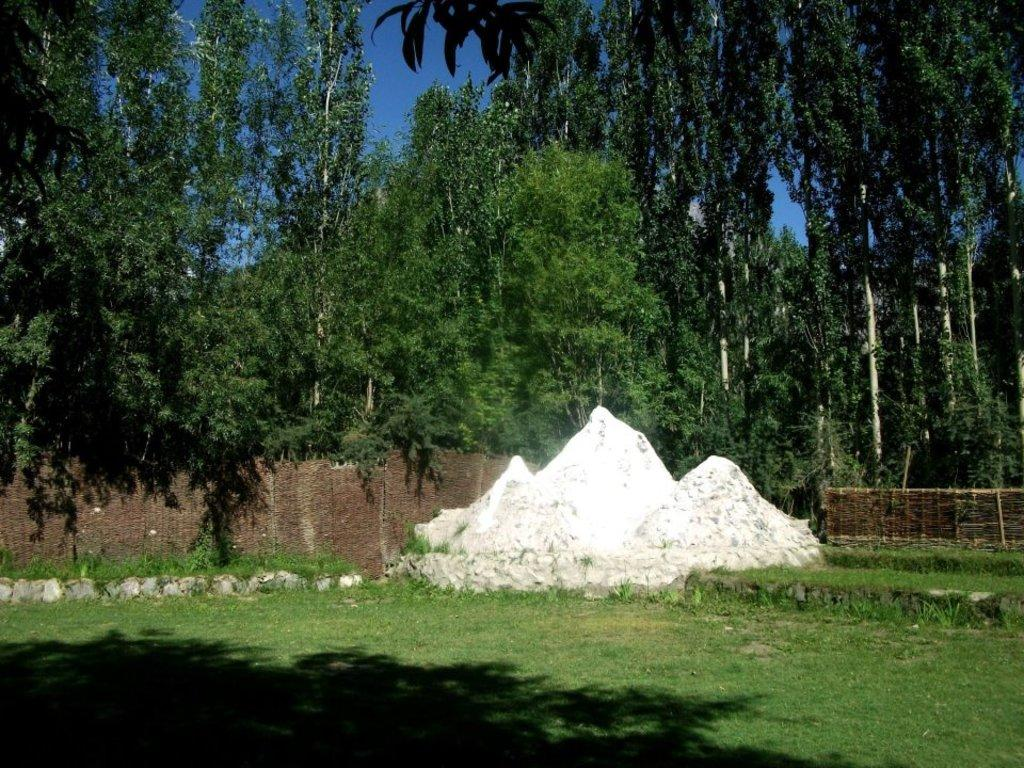What type of barrier can be seen in the image? There is a fence in the image. What type of vegetation is present in the image? There is grass and trees in the image. What part of the natural environment is visible in the image? The sky is visible in the background of the image. What type of alarm is being taught in the image? There is no alarm or teaching activity present in the image. Where is the pocket located in the image? There is no pocket visible in the image. 